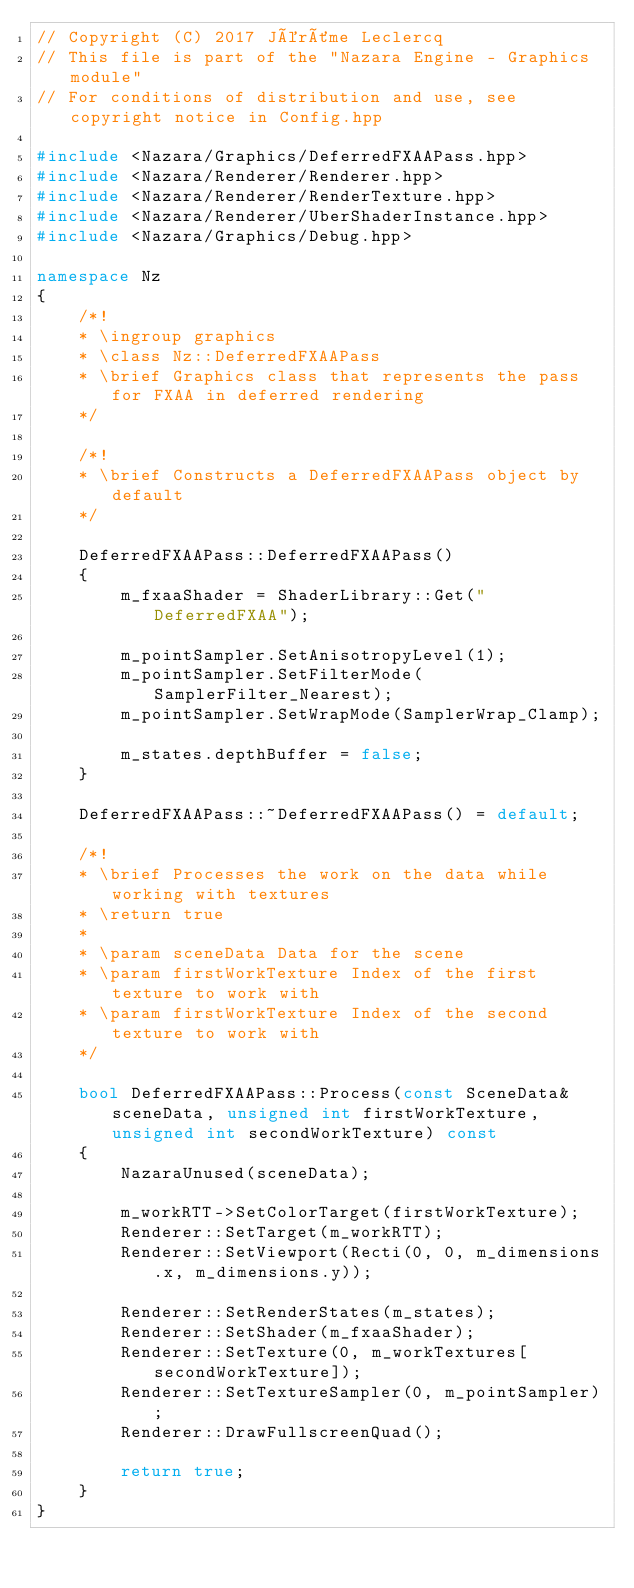<code> <loc_0><loc_0><loc_500><loc_500><_C++_>// Copyright (C) 2017 Jérôme Leclercq
// This file is part of the "Nazara Engine - Graphics module"
// For conditions of distribution and use, see copyright notice in Config.hpp

#include <Nazara/Graphics/DeferredFXAAPass.hpp>
#include <Nazara/Renderer/Renderer.hpp>
#include <Nazara/Renderer/RenderTexture.hpp>
#include <Nazara/Renderer/UberShaderInstance.hpp>
#include <Nazara/Graphics/Debug.hpp>

namespace Nz
{
	/*!
	* \ingroup graphics
	* \class Nz::DeferredFXAAPass
	* \brief Graphics class that represents the pass for FXAA in deferred rendering
	*/

	/*!
	* \brief Constructs a DeferredFXAAPass object by default
	*/

	DeferredFXAAPass::DeferredFXAAPass()
	{
		m_fxaaShader = ShaderLibrary::Get("DeferredFXAA");

		m_pointSampler.SetAnisotropyLevel(1);
		m_pointSampler.SetFilterMode(SamplerFilter_Nearest);
		m_pointSampler.SetWrapMode(SamplerWrap_Clamp);

		m_states.depthBuffer = false;
	}

	DeferredFXAAPass::~DeferredFXAAPass() = default;

	/*!
	* \brief Processes the work on the data while working with textures
	* \return true
	*
	* \param sceneData Data for the scene
	* \param firstWorkTexture Index of the first texture to work with
	* \param firstWorkTexture Index of the second texture to work with
	*/

	bool DeferredFXAAPass::Process(const SceneData& sceneData, unsigned int firstWorkTexture, unsigned int secondWorkTexture) const
	{
		NazaraUnused(sceneData);

		m_workRTT->SetColorTarget(firstWorkTexture);
		Renderer::SetTarget(m_workRTT);
		Renderer::SetViewport(Recti(0, 0, m_dimensions.x, m_dimensions.y));

		Renderer::SetRenderStates(m_states);
		Renderer::SetShader(m_fxaaShader);
		Renderer::SetTexture(0, m_workTextures[secondWorkTexture]);
		Renderer::SetTextureSampler(0, m_pointSampler);
		Renderer::DrawFullscreenQuad();

		return true;
	}
}
</code> 